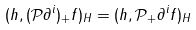<formula> <loc_0><loc_0><loc_500><loc_500>( h , ( \mathcal { P } \partial ^ { i } ) _ { + } f ) _ { H } = ( h , \mathcal { P } _ { + } \partial ^ { i } f ) _ { H }</formula> 